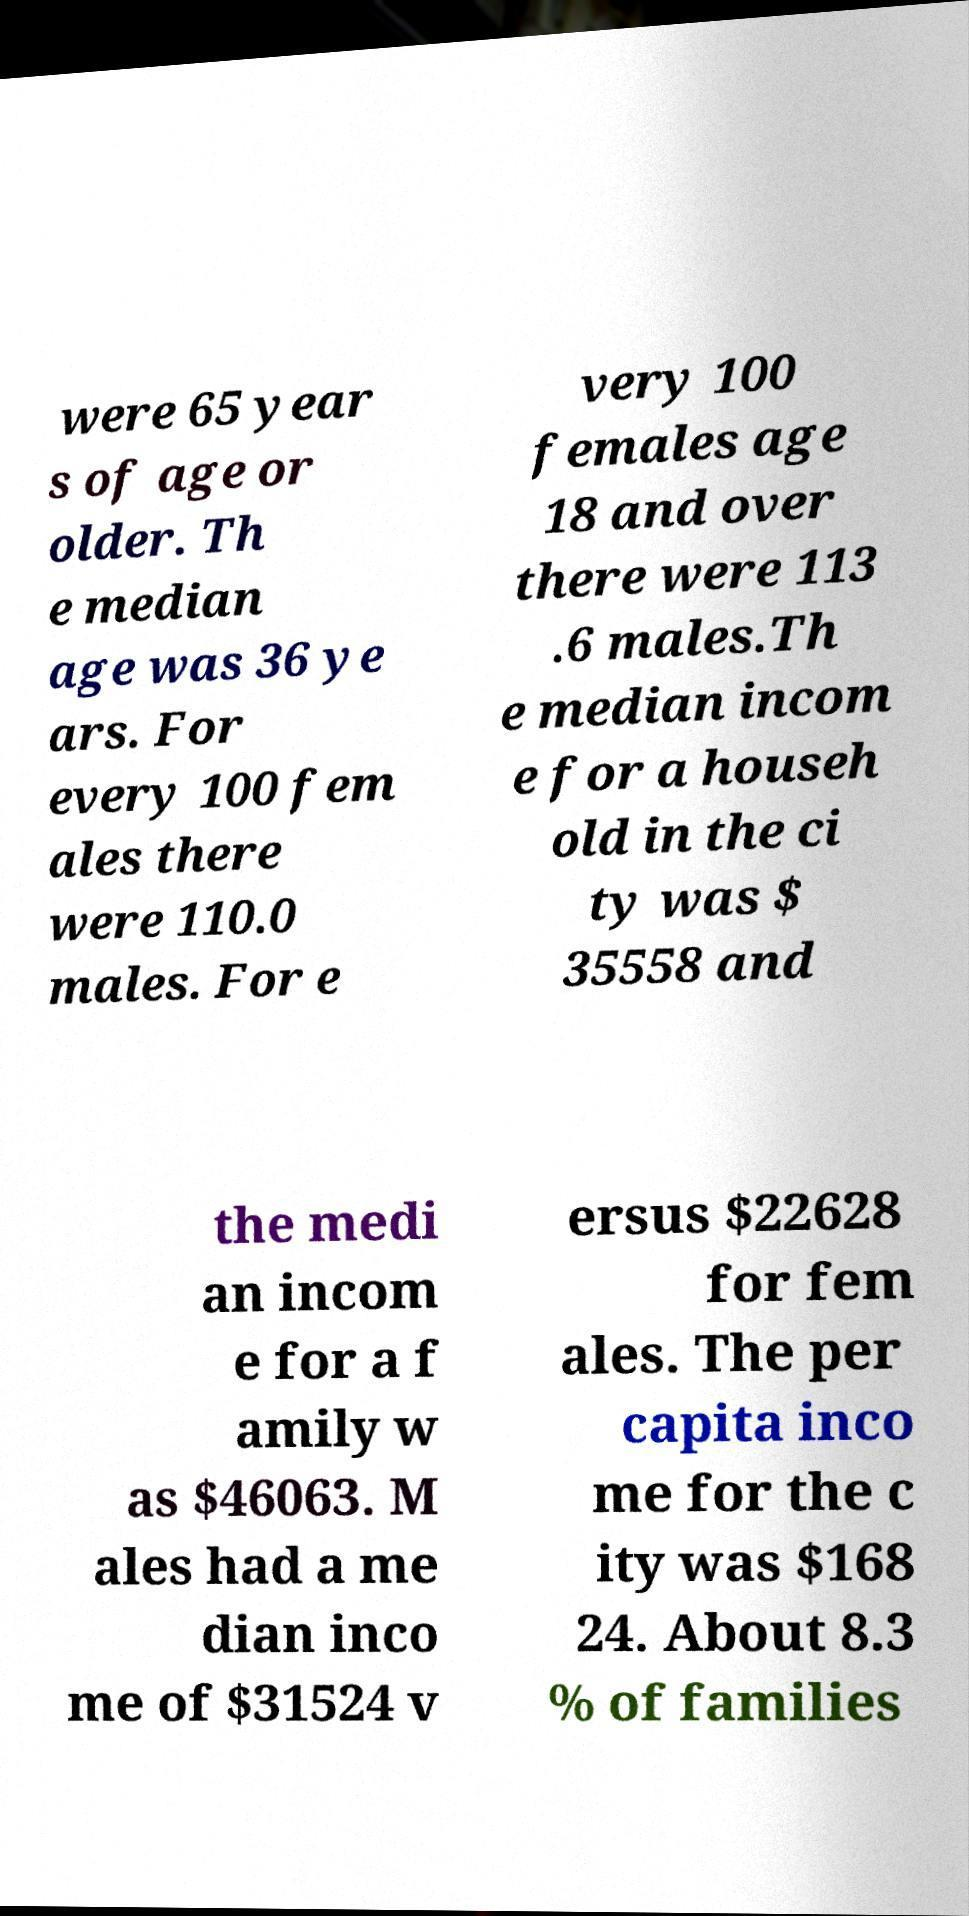For documentation purposes, I need the text within this image transcribed. Could you provide that? were 65 year s of age or older. Th e median age was 36 ye ars. For every 100 fem ales there were 110.0 males. For e very 100 females age 18 and over there were 113 .6 males.Th e median incom e for a househ old in the ci ty was $ 35558 and the medi an incom e for a f amily w as $46063. M ales had a me dian inco me of $31524 v ersus $22628 for fem ales. The per capita inco me for the c ity was $168 24. About 8.3 % of families 